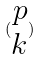Convert formula to latex. <formula><loc_0><loc_0><loc_500><loc_500>( \begin{matrix} p \\ k \end{matrix} )</formula> 